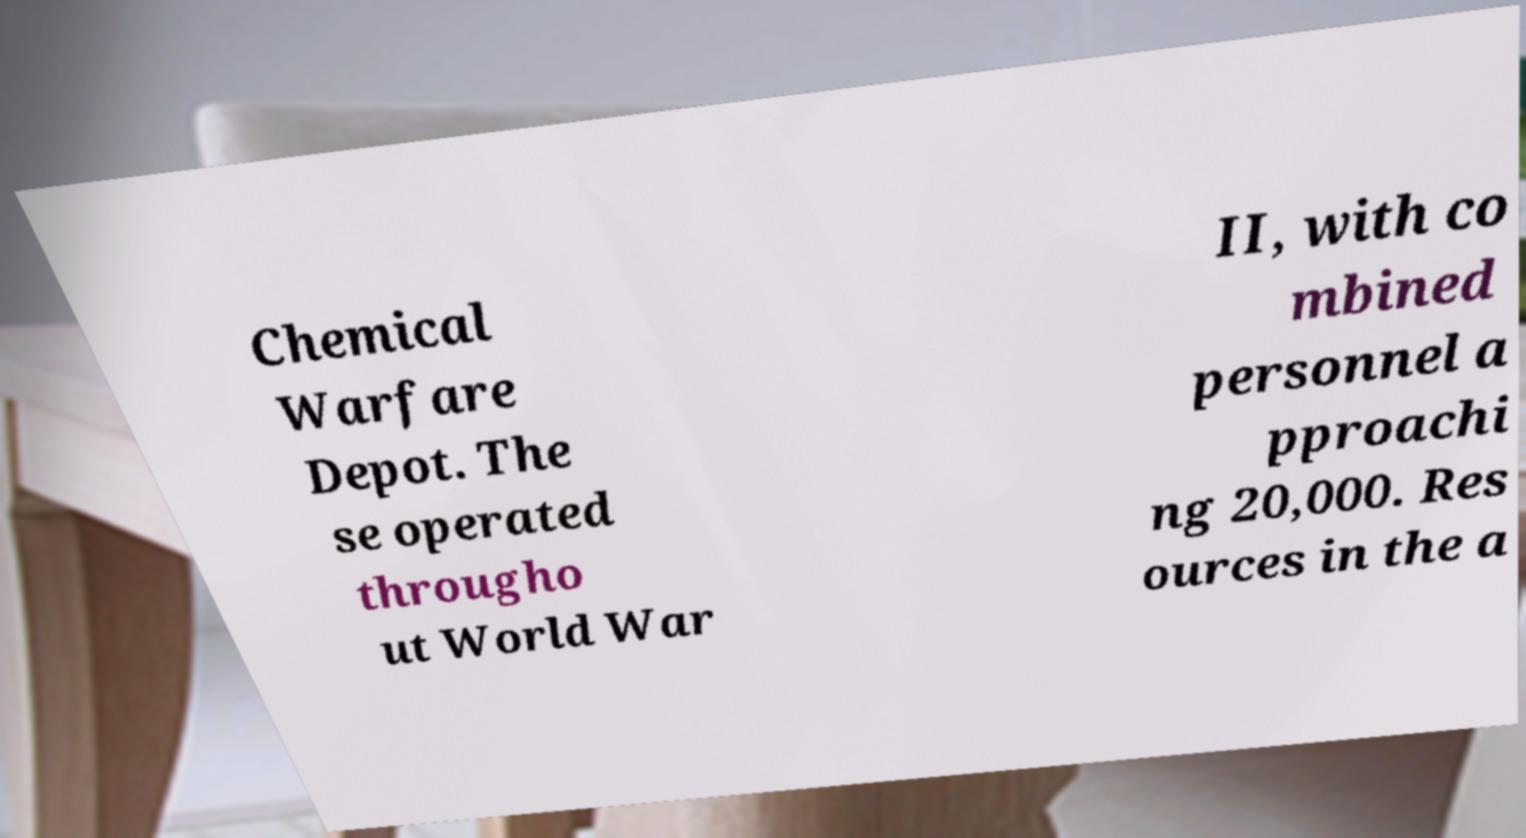For documentation purposes, I need the text within this image transcribed. Could you provide that? Chemical Warfare Depot. The se operated througho ut World War II, with co mbined personnel a pproachi ng 20,000. Res ources in the a 